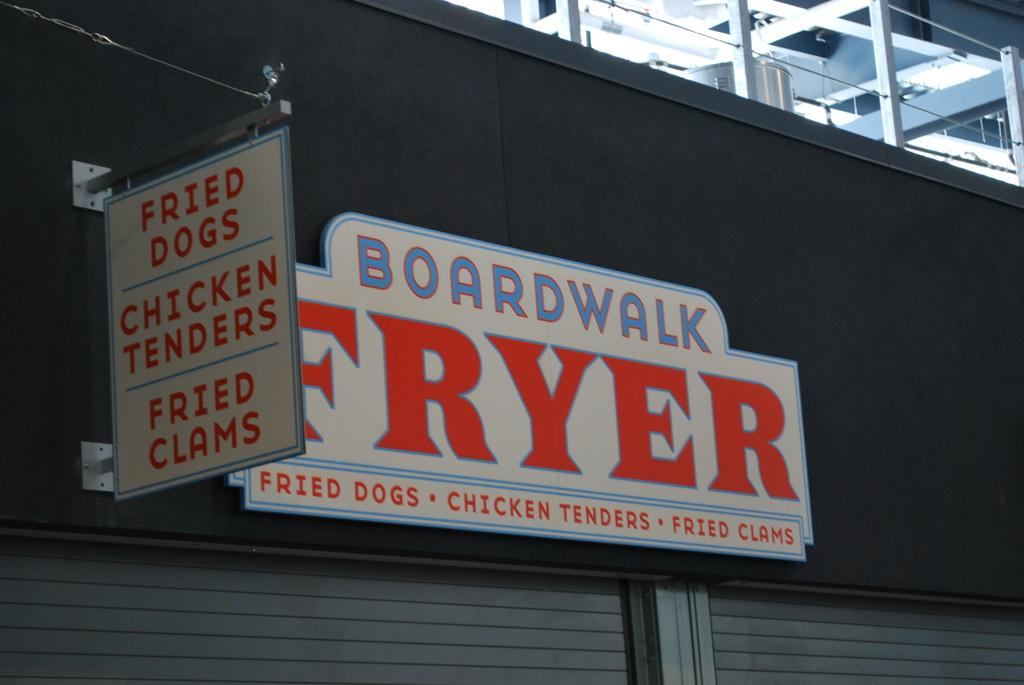What can be seen on the boards in the image? There is writing on the boards in the image. What color is the wall that the boards are attached to? The wall is black in color. What type of window treatment is visible in the image? There are shutters visible in the image. What other objects can be seen in the image besides the boards and shutters? There are other objects present in the image. Can you tell me how much credit the person in the image has on their account? There is no information about a person or their credit in the image; it only shows boards with writing on them, a black wall, and shutters. 